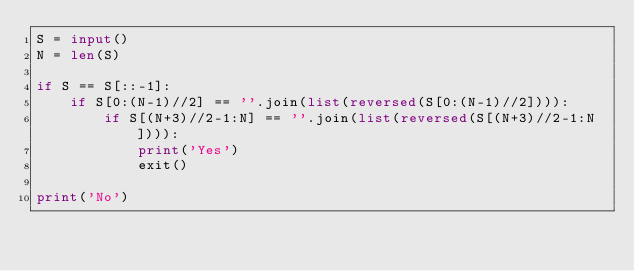Convert code to text. <code><loc_0><loc_0><loc_500><loc_500><_Python_>S = input()
N = len(S)

if S == S[::-1]:
    if S[0:(N-1)//2] == ''.join(list(reversed(S[0:(N-1)//2]))):
        if S[(N+3)//2-1:N] == ''.join(list(reversed(S[(N+3)//2-1:N]))):
            print('Yes')
            exit()

print('No')</code> 